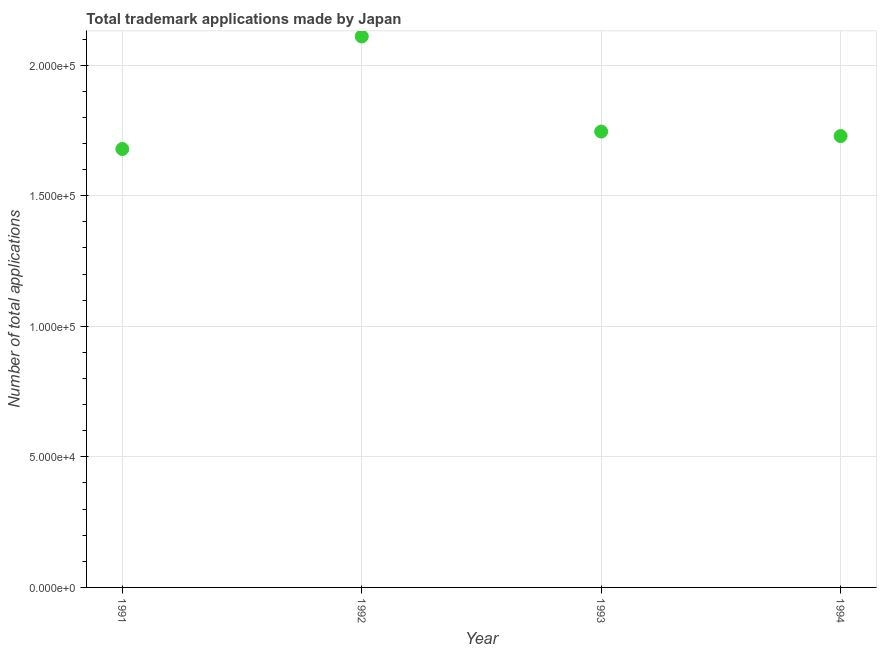What is the number of trademark applications in 1992?
Give a very brief answer. 2.11e+05. Across all years, what is the maximum number of trademark applications?
Offer a terse response. 2.11e+05. Across all years, what is the minimum number of trademark applications?
Provide a succinct answer. 1.68e+05. In which year was the number of trademark applications minimum?
Provide a short and direct response. 1991. What is the sum of the number of trademark applications?
Provide a succinct answer. 7.26e+05. What is the difference between the number of trademark applications in 1991 and 1993?
Make the answer very short. -6679. What is the average number of trademark applications per year?
Make the answer very short. 1.82e+05. What is the median number of trademark applications?
Provide a short and direct response. 1.74e+05. What is the ratio of the number of trademark applications in 1991 to that in 1993?
Ensure brevity in your answer.  0.96. Is the number of trademark applications in 1992 less than that in 1994?
Provide a short and direct response. No. What is the difference between the highest and the second highest number of trademark applications?
Provide a short and direct response. 3.64e+04. Is the sum of the number of trademark applications in 1991 and 1994 greater than the maximum number of trademark applications across all years?
Keep it short and to the point. Yes. What is the difference between the highest and the lowest number of trademark applications?
Your answer should be very brief. 4.31e+04. In how many years, is the number of trademark applications greater than the average number of trademark applications taken over all years?
Offer a very short reply. 1. How many dotlines are there?
Your answer should be very brief. 1. How many years are there in the graph?
Your answer should be compact. 4. Does the graph contain any zero values?
Ensure brevity in your answer.  No. Does the graph contain grids?
Give a very brief answer. Yes. What is the title of the graph?
Give a very brief answer. Total trademark applications made by Japan. What is the label or title of the Y-axis?
Provide a short and direct response. Number of total applications. What is the Number of total applications in 1991?
Keep it short and to the point. 1.68e+05. What is the Number of total applications in 1992?
Ensure brevity in your answer.  2.11e+05. What is the Number of total applications in 1993?
Make the answer very short. 1.75e+05. What is the Number of total applications in 1994?
Provide a succinct answer. 1.73e+05. What is the difference between the Number of total applications in 1991 and 1992?
Keep it short and to the point. -4.31e+04. What is the difference between the Number of total applications in 1991 and 1993?
Your response must be concise. -6679. What is the difference between the Number of total applications in 1991 and 1994?
Ensure brevity in your answer.  -4953. What is the difference between the Number of total applications in 1992 and 1993?
Provide a short and direct response. 3.64e+04. What is the difference between the Number of total applications in 1992 and 1994?
Offer a terse response. 3.82e+04. What is the difference between the Number of total applications in 1993 and 1994?
Offer a terse response. 1726. What is the ratio of the Number of total applications in 1991 to that in 1992?
Your answer should be compact. 0.8. What is the ratio of the Number of total applications in 1991 to that in 1993?
Your answer should be very brief. 0.96. What is the ratio of the Number of total applications in 1992 to that in 1993?
Give a very brief answer. 1.21. What is the ratio of the Number of total applications in 1992 to that in 1994?
Offer a very short reply. 1.22. 